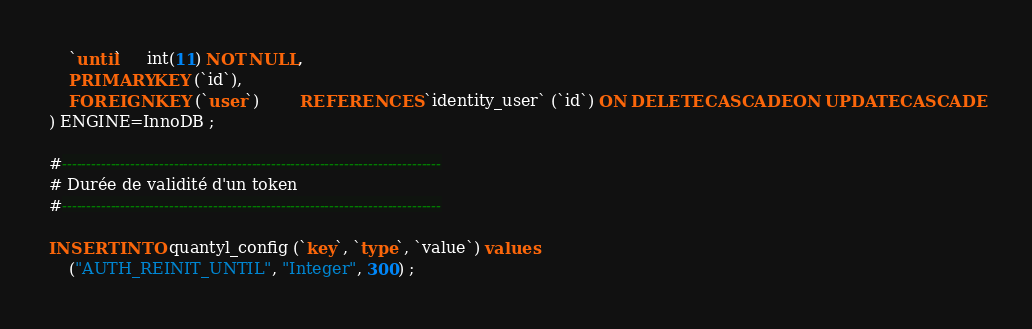<code> <loc_0><loc_0><loc_500><loc_500><_SQL_>    `until`     int(11) NOT NULL,
    PRIMARY KEY (`id`),
    FOREIGN KEY (`user`)        REFERENCES `identity_user` (`id`) ON DELETE CASCADE ON UPDATE CASCADE
) ENGINE=InnoDB ;

#------------------------------------------------------------------------------
# Durée de validité d'un token
#------------------------------------------------------------------------------

INSERT INTO quantyl_config (`key`, `type`, `value`) values
    ("AUTH_REINIT_UNTIL", "Integer", 300) ;
</code> 